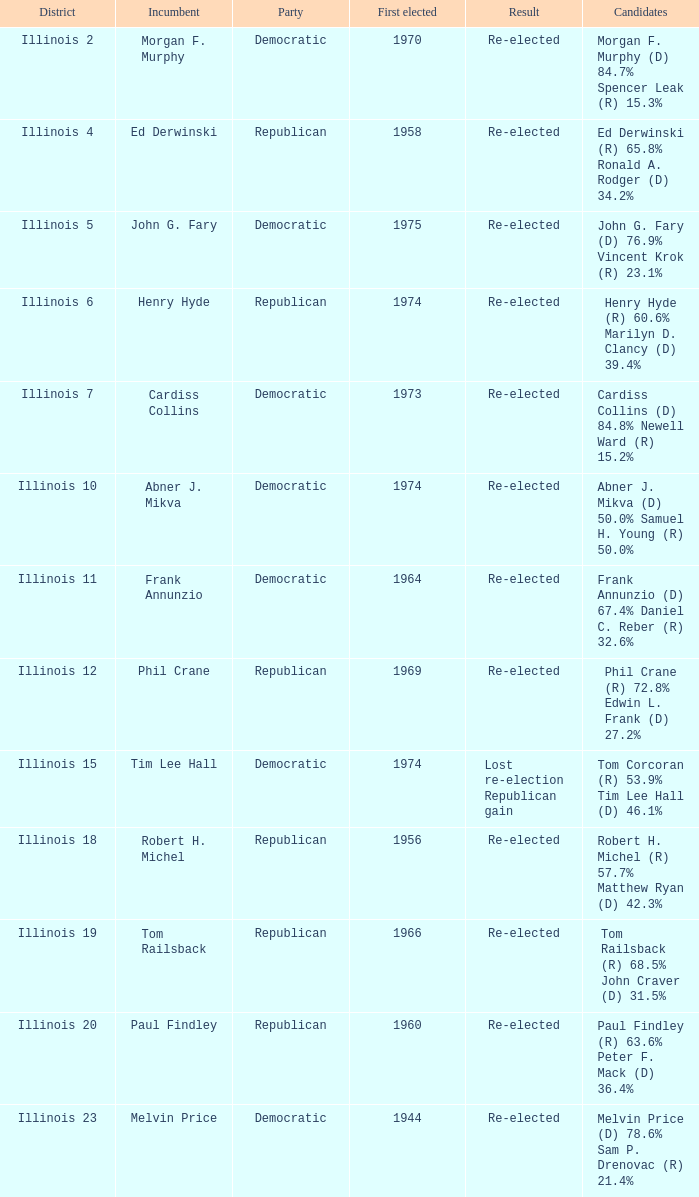Name the first elected for abner j. mikva 1974.0. 